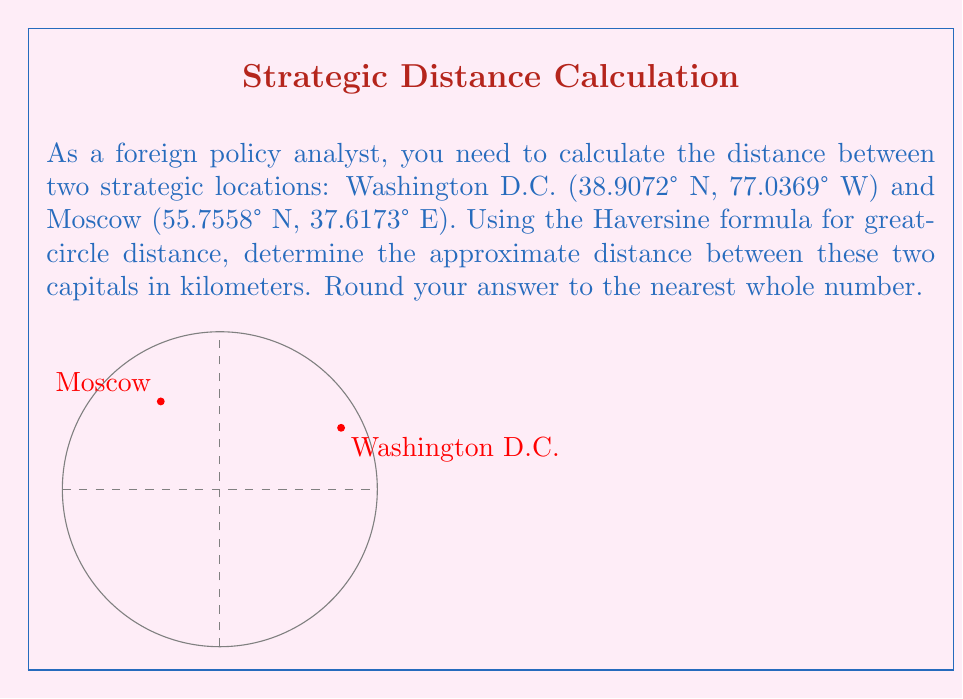Can you solve this math problem? To calculate the distance between two points on Earth using latitude and longitude, we'll use the Haversine formula:

1) First, convert the latitudes and longitudes from degrees to radians:
   $$\text{rad} = \text{deg} \times \frac{\pi}{180}$$

   Washington D.C.: $\text{lat}_1 = 38.9072° \times \frac{\pi}{180} = 0.6789 \text{ rad}$
                    $\text{lon}_1 = -77.0369° \times \frac{\pi}{180} = -1.3442 \text{ rad}$
   Moscow:          $\text{lat}_2 = 55.7558° \times \frac{\pi}{180} = 0.9732 \text{ rad}$
                    $\text{lon}_2 = 37.6173° \times \frac{\pi}{180} = 0.6563 \text{ rad}$

2) Calculate the difference in longitude:
   $$\Delta\text{lon} = \text{lon}_2 - \text{lon}_1 = 0.6563 - (-1.3442) = 2.0005 \text{ rad}$$

3) Apply the Haversine formula:
   $$a = \sin^2(\frac{\Delta\text{lat}}{2}) + \cos(\text{lat}_1) \times \cos(\text{lat}_2) \times \sin^2(\frac{\Delta\text{lon}}{2})$$
   $$c = 2 \times \text{atan2}(\sqrt{a}, \sqrt{1-a})$$
   $$d = R \times c$$

   Where $R$ is the Earth's radius (approximately 6371 km)

4) Calculate $a$:
   $$a = \sin^2(\frac{0.9732 - 0.6789}{2}) + \cos(0.6789) \times \cos(0.9732) \times \sin^2(\frac{2.0005}{2}) = 0.3178$$

5) Calculate $c$:
   $$c = 2 \times \text{atan2}(\sqrt{0.3178}, \sqrt{1-0.3178}) = 1.2010$$

6) Calculate the distance $d$:
   $$d = 6371 \times 1.2010 = 7651.81 \text{ km}$$

7) Round to the nearest whole number:
   $$d \approx 7652 \text{ km}$$
Answer: 7652 km 